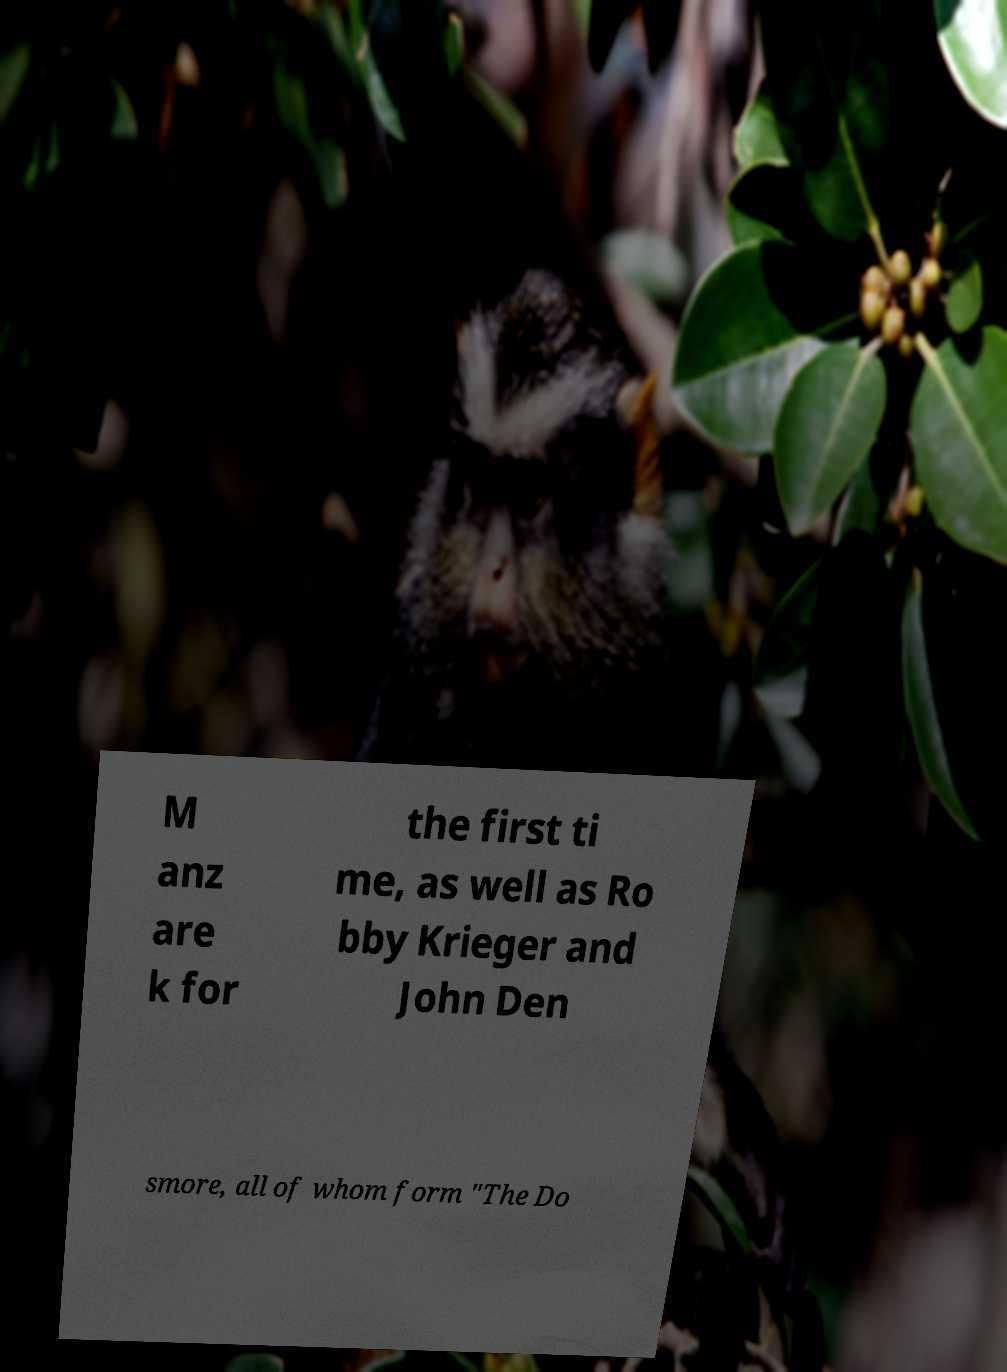Can you accurately transcribe the text from the provided image for me? M anz are k for the first ti me, as well as Ro bby Krieger and John Den smore, all of whom form "The Do 